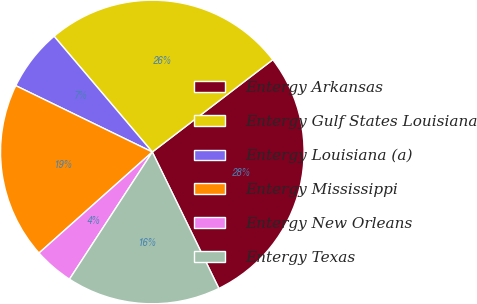Convert chart to OTSL. <chart><loc_0><loc_0><loc_500><loc_500><pie_chart><fcel>Entergy Arkansas<fcel>Entergy Gulf States Louisiana<fcel>Entergy Louisiana (a)<fcel>Entergy Mississippi<fcel>Entergy New Orleans<fcel>Entergy Texas<nl><fcel>28.18%<fcel>25.8%<fcel>6.6%<fcel>18.79%<fcel>4.22%<fcel>16.41%<nl></chart> 